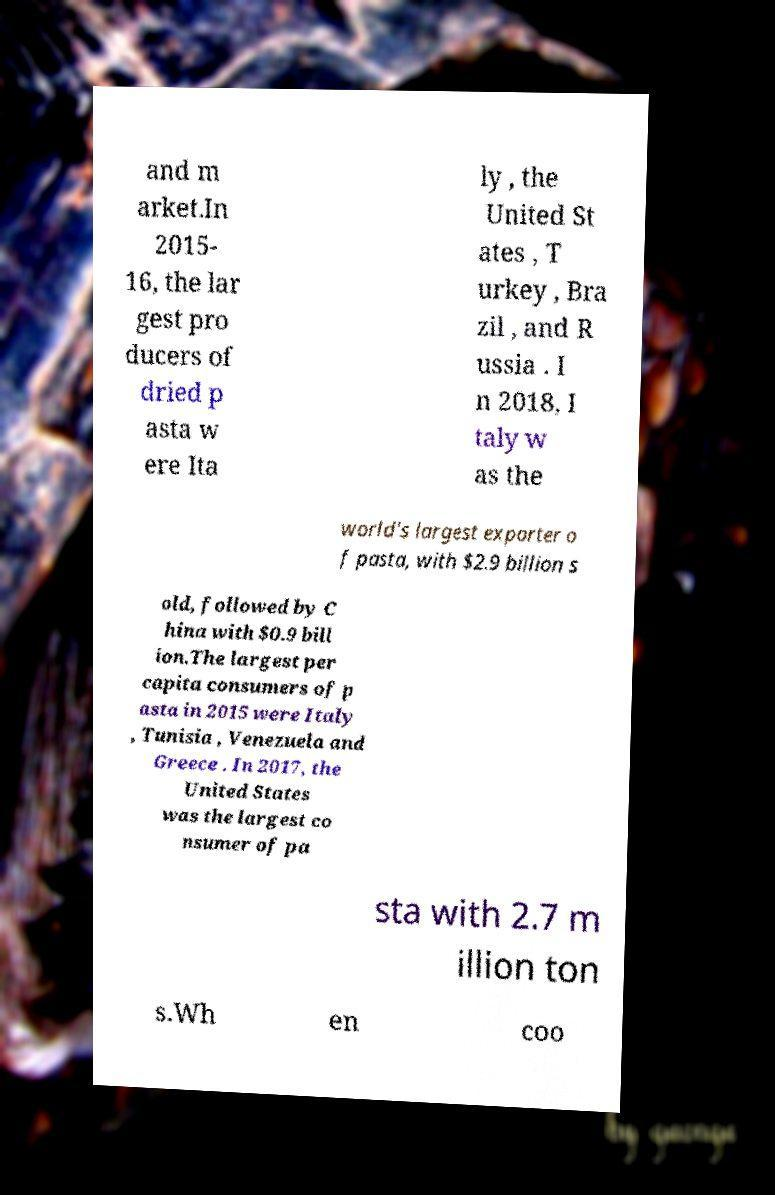There's text embedded in this image that I need extracted. Can you transcribe it verbatim? and m arket.In 2015- 16, the lar gest pro ducers of dried p asta w ere Ita ly , the United St ates , T urkey , Bra zil , and R ussia . I n 2018, I taly w as the world's largest exporter o f pasta, with $2.9 billion s old, followed by C hina with $0.9 bill ion.The largest per capita consumers of p asta in 2015 were Italy , Tunisia , Venezuela and Greece . In 2017, the United States was the largest co nsumer of pa sta with 2.7 m illion ton s.Wh en coo 